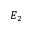Convert formula to latex. <formula><loc_0><loc_0><loc_500><loc_500>E _ { 2 }</formula> 